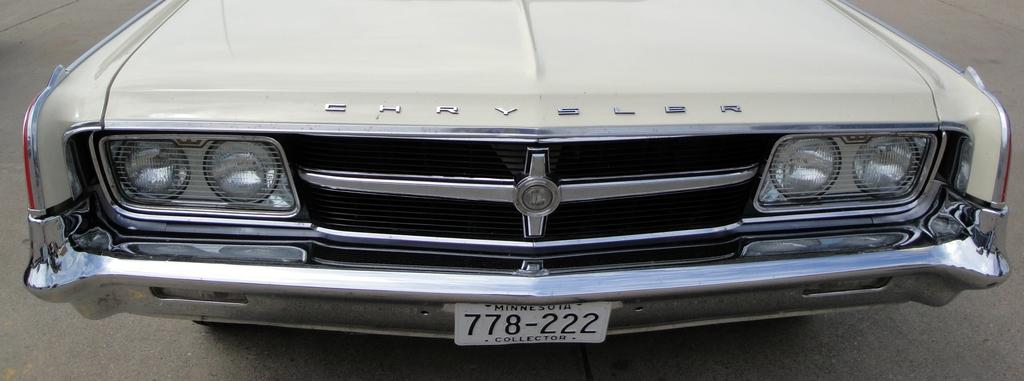What is the main subject of the image? The main subject of the image is a car. Where is the car located in the image? The car is on the road in the image. What type of square can be seen on the car's chin in the image? There is no square or chin present on the car in the image. Is the car being used as a prison in the image? No, the car is not being used as a prison in the image. 